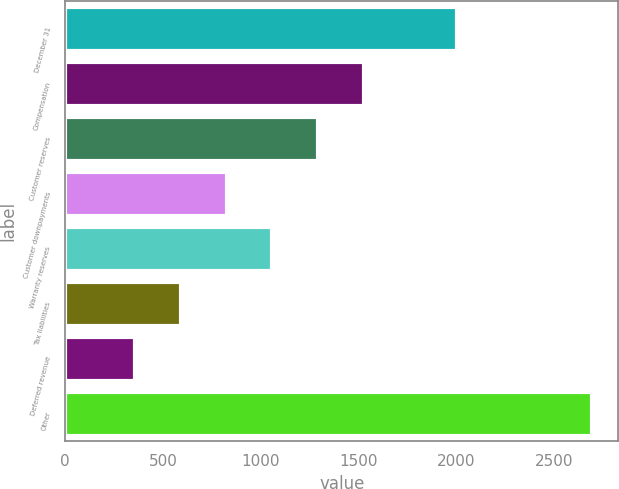Convert chart. <chart><loc_0><loc_0><loc_500><loc_500><bar_chart><fcel>December 31<fcel>Compensation<fcel>Customer reserves<fcel>Customer downpayments<fcel>Warranty reserves<fcel>Tax liabilities<fcel>Deferred revenue<fcel>Other<nl><fcel>2004<fcel>1527<fcel>1293.6<fcel>826.8<fcel>1060.2<fcel>593.4<fcel>360<fcel>2694<nl></chart> 